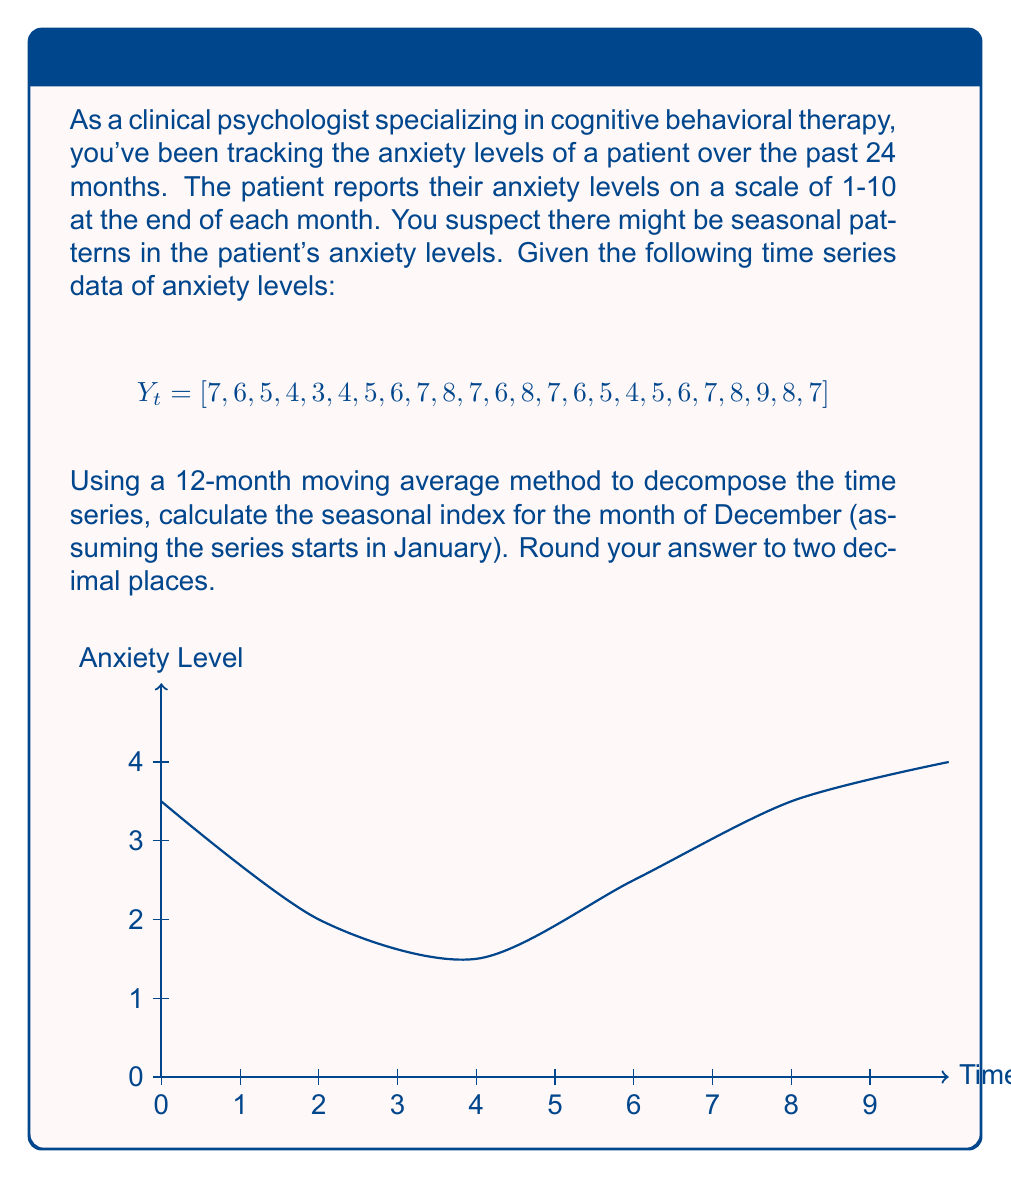Provide a solution to this math problem. To decompose the time series and calculate the seasonal index for December, we'll follow these steps:

1) Calculate the 12-month centered moving average:
   First, we compute the simple 12-month moving average, then center it.
   
   $MA_{12} = [5.50, 5.58, 5.67, 5.75, 5.83, 5.92, 6.00, 6.08, 6.17, 6.25, 6.33, 6.42]$
   
   Centered MA: $MA'_{12} = [5.54, 5.63, 5.71, 5.79, 5.88, 5.96, 6.04, 6.13, 6.21, 6.29, 6.38]$

2) Calculate the ratio of actual values to moving average:
   $R_t = Y_t / MA'_{12}$
   
   For December (months 12 and 24):
   $R_{12} = 6 / 5.96 = 1.0067$
   $R_{24} = 7 / 6.38 = 1.0972$

3) Calculate the seasonal index for December:
   Average the ratios for December:
   $SI_{Dec} = (1.0067 + 1.0972) / 2 = 1.0520$

4) Round to two decimal places:
   $SI_{Dec} ≈ 1.05$

Thus, the seasonal index for December is approximately 1.05, indicating that anxiety levels in December tend to be about 5% higher than the trend.
Answer: 1.05 